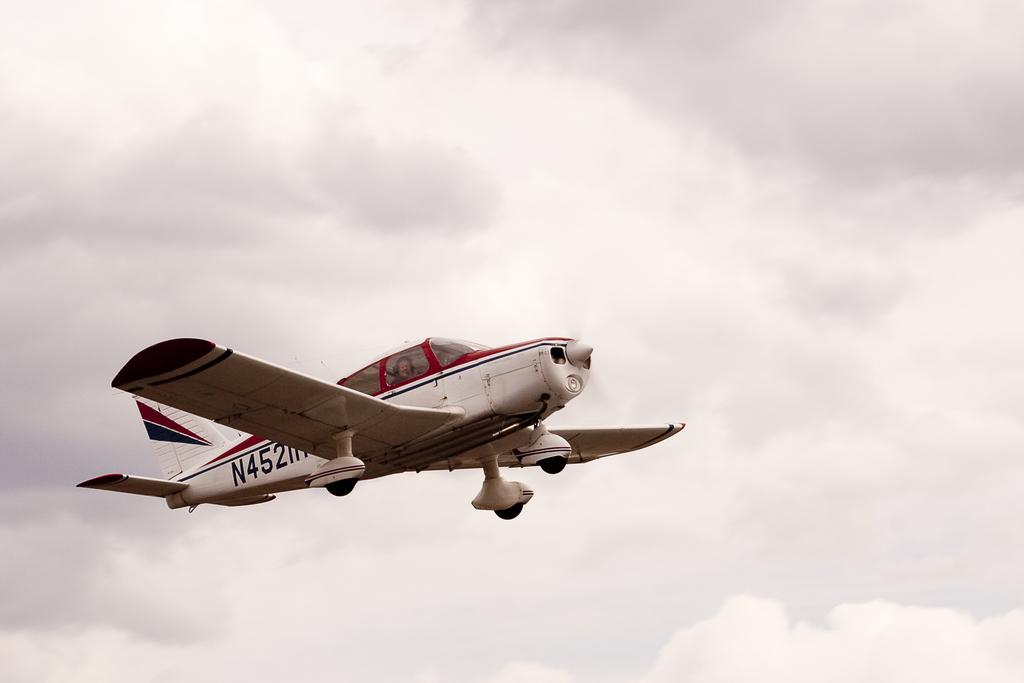What is the main subject in the foreground of the image? There is an airplane in the foreground of the image. What is the airplane's position in the image? The airplane is in the air. What can be seen in the background of the image? There are clouds visible in the background of the image. What type of pizzas can be seen in the image? There are no pizzas present in the image; it features an airplane in the air. 